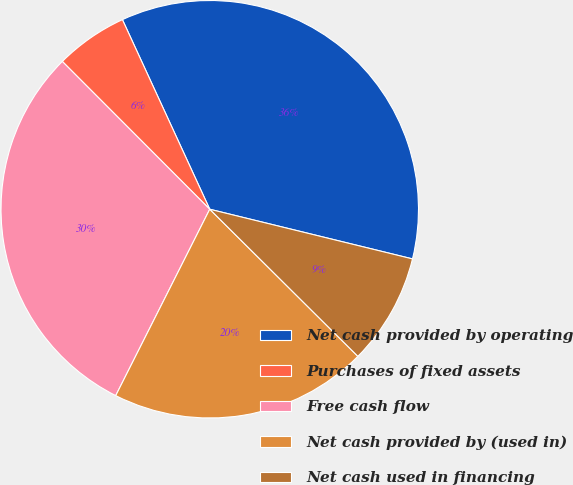Convert chart. <chart><loc_0><loc_0><loc_500><loc_500><pie_chart><fcel>Net cash provided by operating<fcel>Purchases of fixed assets<fcel>Free cash flow<fcel>Net cash provided by (used in)<fcel>Net cash used in financing<nl><fcel>35.69%<fcel>5.61%<fcel>30.08%<fcel>19.99%<fcel>8.62%<nl></chart> 